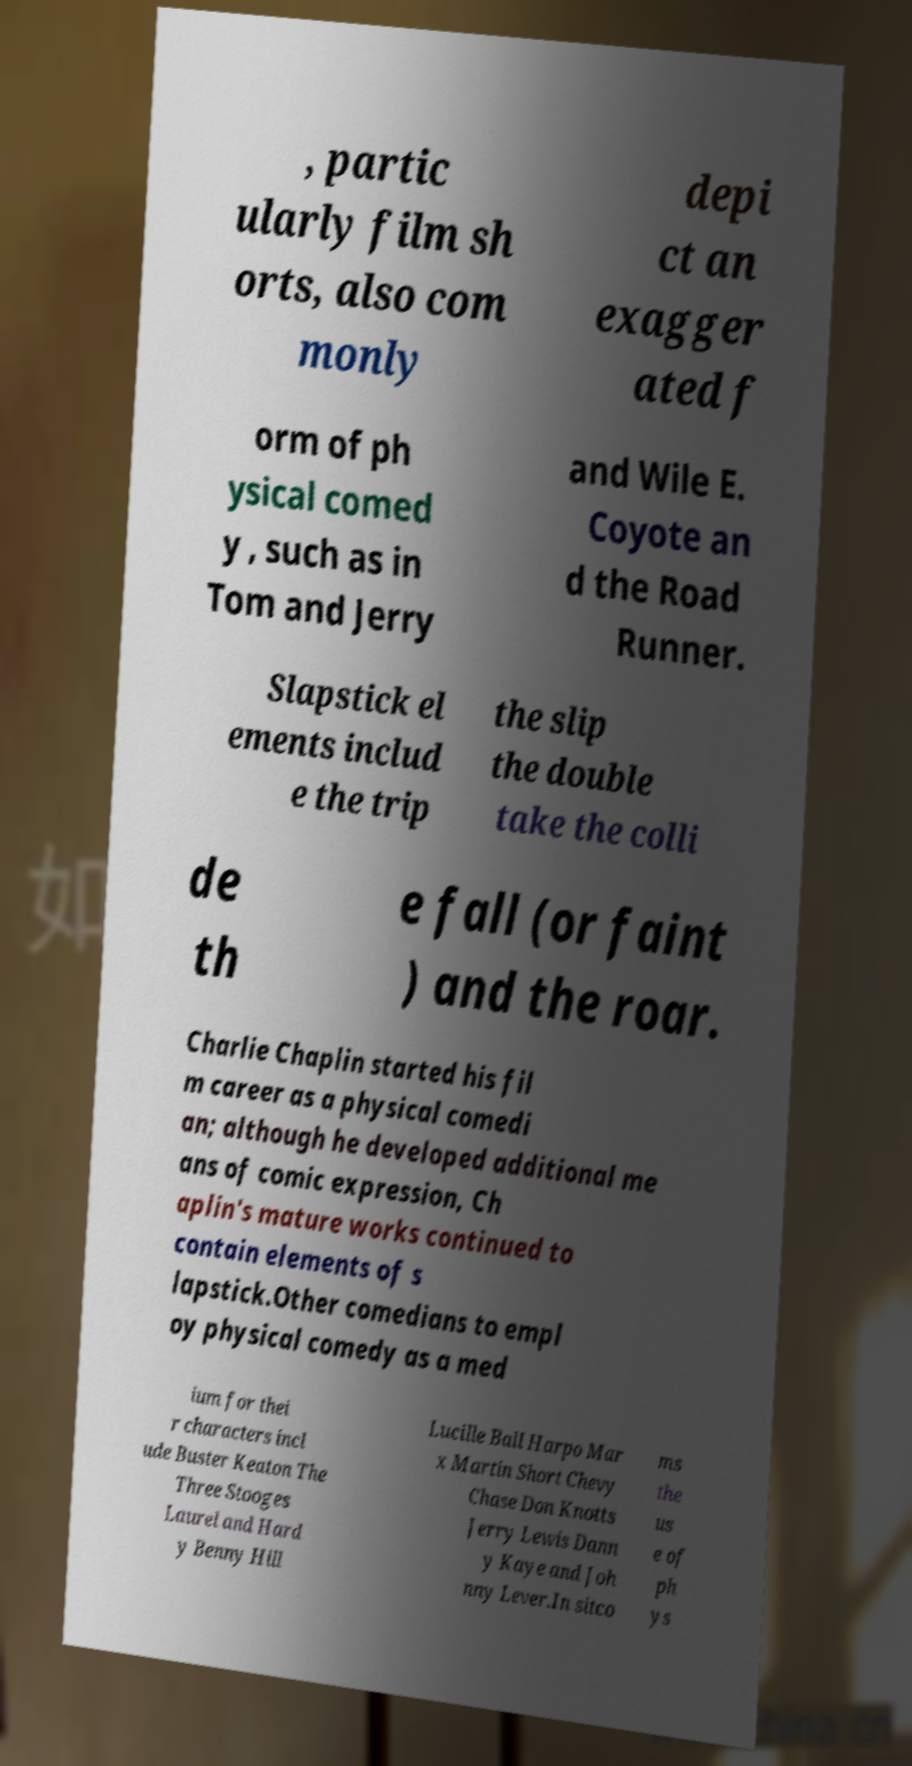Can you accurately transcribe the text from the provided image for me? , partic ularly film sh orts, also com monly depi ct an exagger ated f orm of ph ysical comed y , such as in Tom and Jerry and Wile E. Coyote an d the Road Runner. Slapstick el ements includ e the trip the slip the double take the colli de th e fall (or faint ) and the roar. Charlie Chaplin started his fil m career as a physical comedi an; although he developed additional me ans of comic expression, Ch aplin's mature works continued to contain elements of s lapstick.Other comedians to empl oy physical comedy as a med ium for thei r characters incl ude Buster Keaton The Three Stooges Laurel and Hard y Benny Hill Lucille Ball Harpo Mar x Martin Short Chevy Chase Don Knotts Jerry Lewis Dann y Kaye and Joh nny Lever.In sitco ms the us e of ph ys 